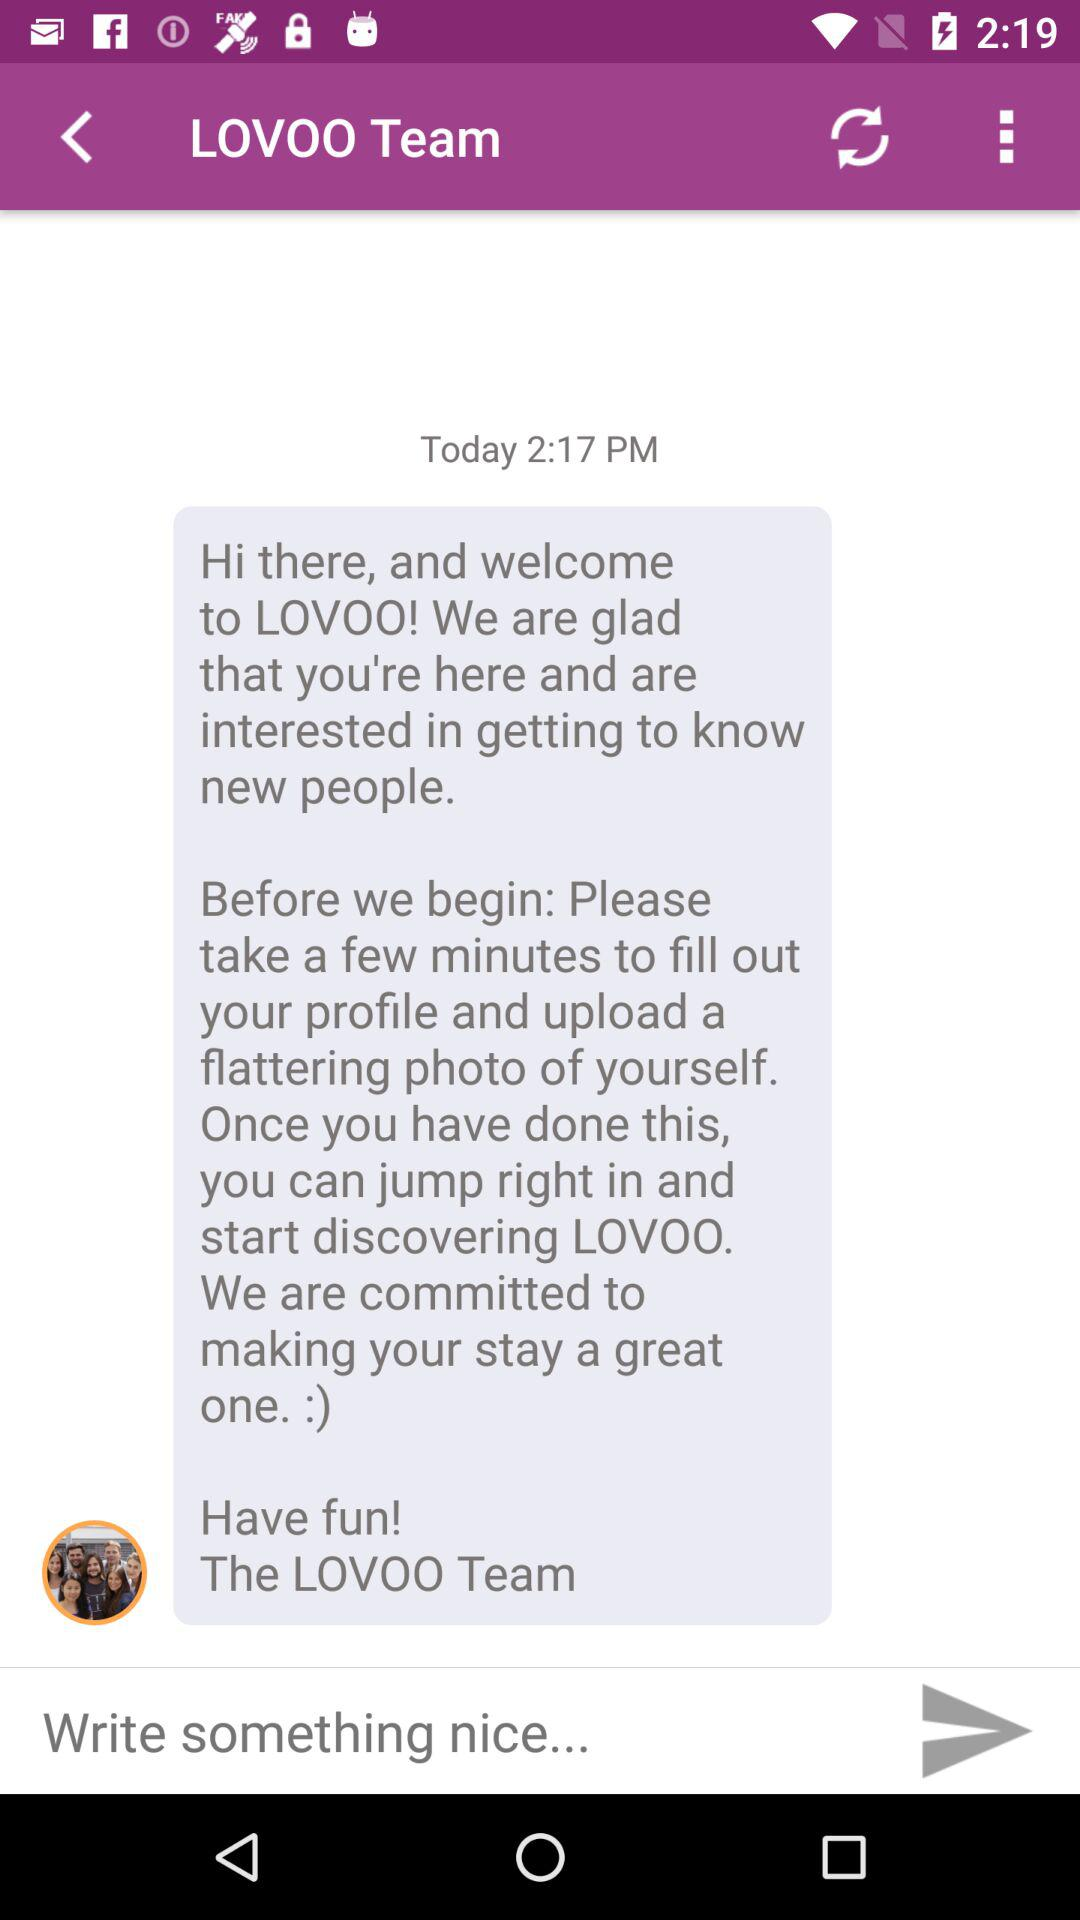What is the date of the message?
When the provided information is insufficient, respond with <no answer>. <no answer> 